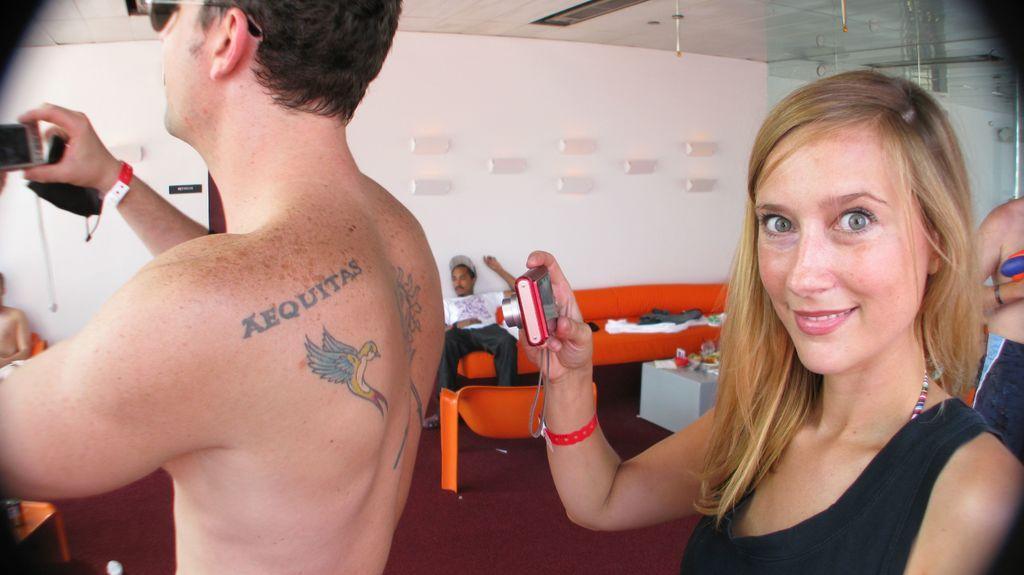Please provide a concise description of this image. In the foreground of this image, there is a man and a woman holding cameras. In the background, there are two people sitting on the couch and also we can see few clothes on the couch, few objects on the table, wall, ceiling and a man on the right. 